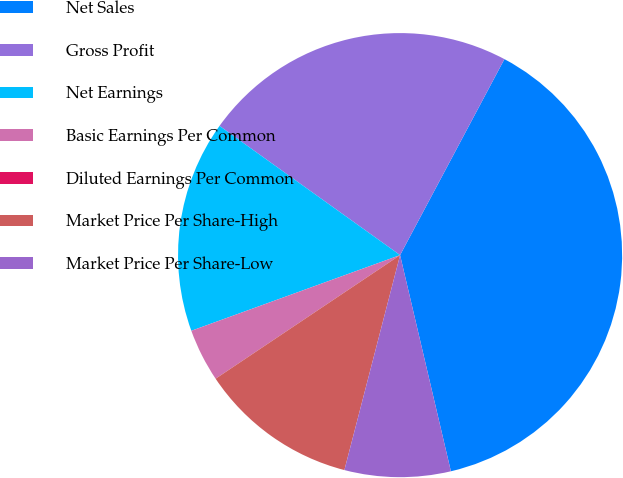Convert chart. <chart><loc_0><loc_0><loc_500><loc_500><pie_chart><fcel>Net Sales<fcel>Gross Profit<fcel>Net Earnings<fcel>Basic Earnings Per Common<fcel>Diluted Earnings Per Common<fcel>Market Price Per Share-High<fcel>Market Price Per Share-Low<nl><fcel>38.54%<fcel>22.9%<fcel>15.42%<fcel>3.86%<fcel>0.0%<fcel>11.57%<fcel>7.71%<nl></chart> 